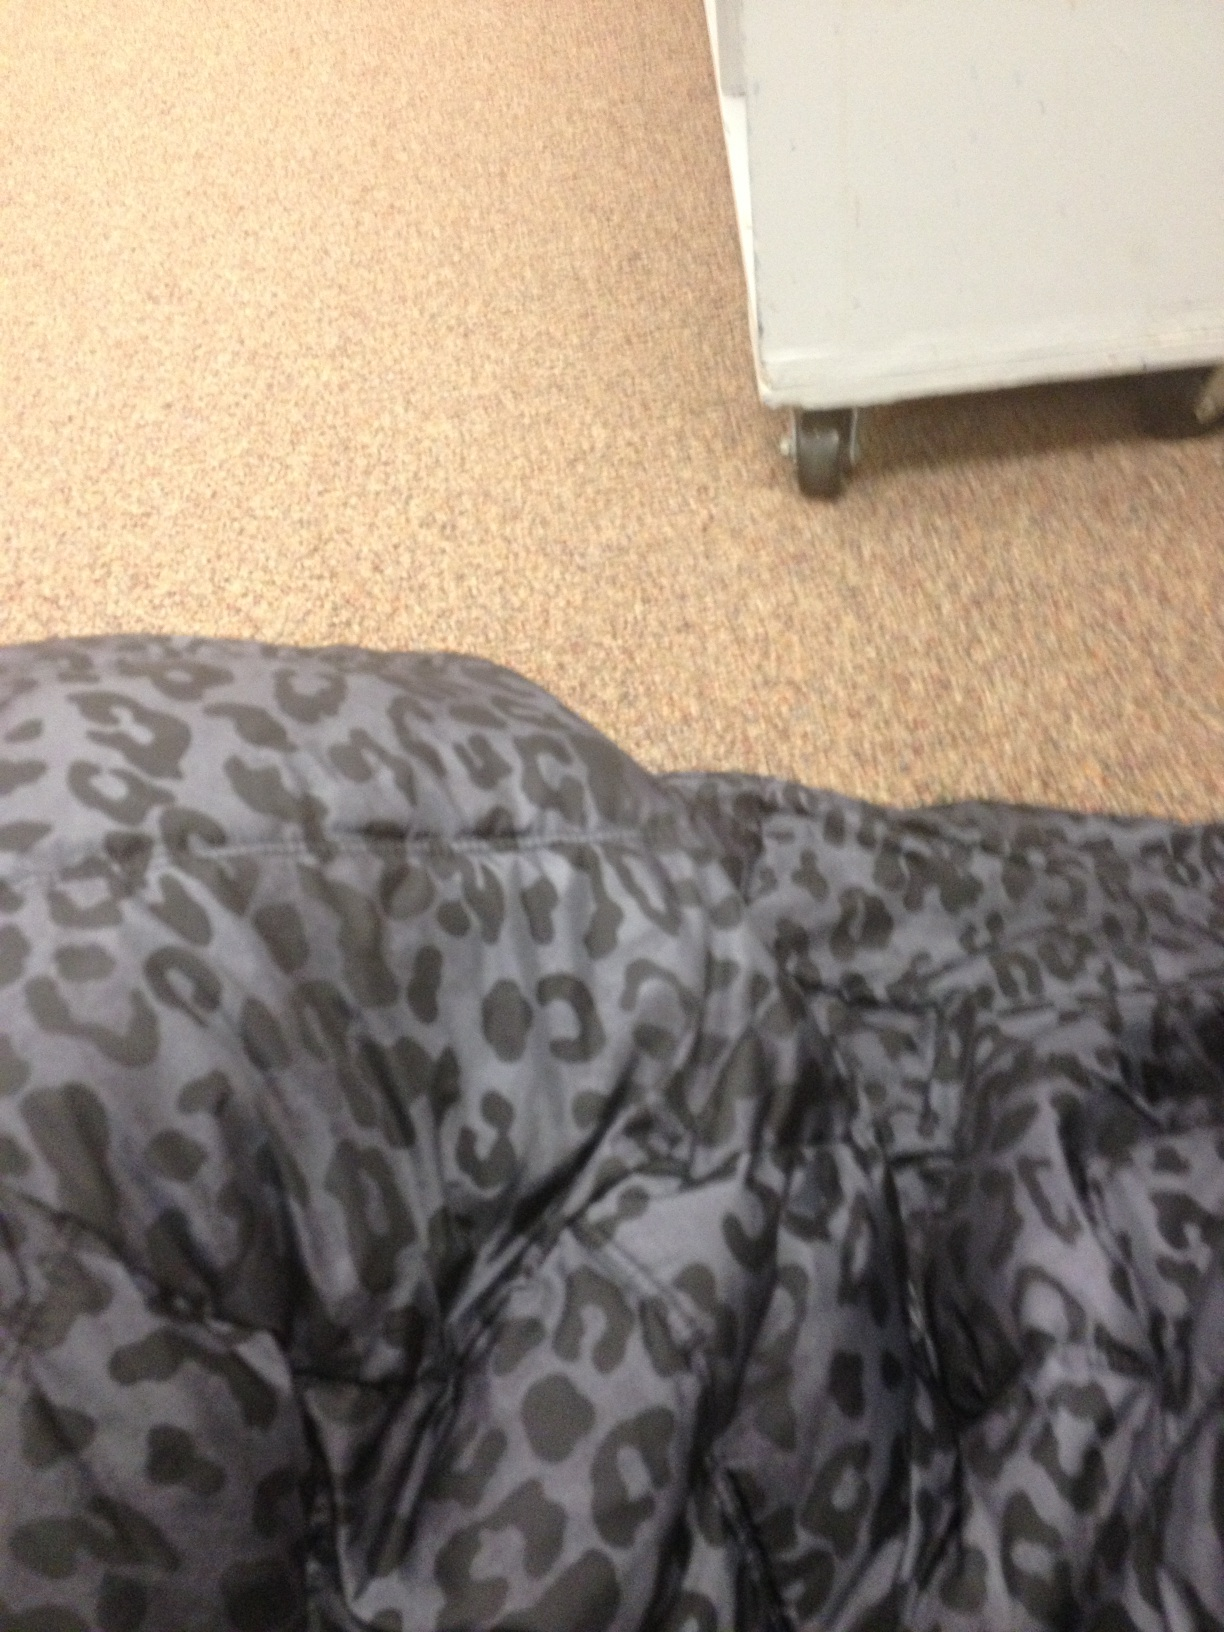Where might this fabric be typically found? Such patterned fabric is commonly seen in fashion retail stores, either in the clothing section or as part of displays and merchandise like handbags or shoes. 